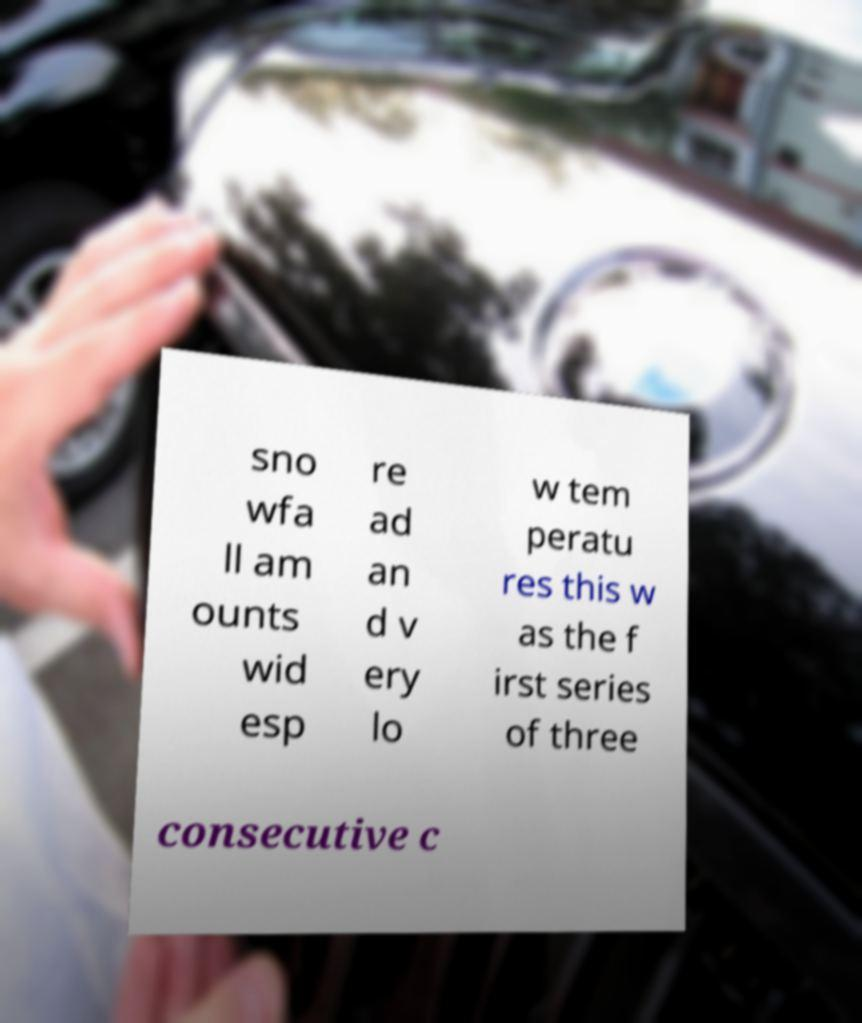I need the written content from this picture converted into text. Can you do that? sno wfa ll am ounts wid esp re ad an d v ery lo w tem peratu res this w as the f irst series of three consecutive c 